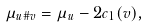<formula> <loc_0><loc_0><loc_500><loc_500>\mu _ { u \# v } = \mu _ { u } - 2 c _ { 1 } ( v ) ,</formula> 